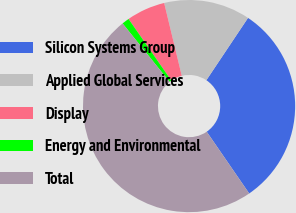Convert chart to OTSL. <chart><loc_0><loc_0><loc_500><loc_500><pie_chart><fcel>Silicon Systems Group<fcel>Applied Global Services<fcel>Display<fcel>Energy and Environmental<fcel>Total<nl><fcel>31.03%<fcel>13.15%<fcel>5.89%<fcel>1.12%<fcel>48.8%<nl></chart> 